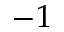<formula> <loc_0><loc_0><loc_500><loc_500>- 1</formula> 